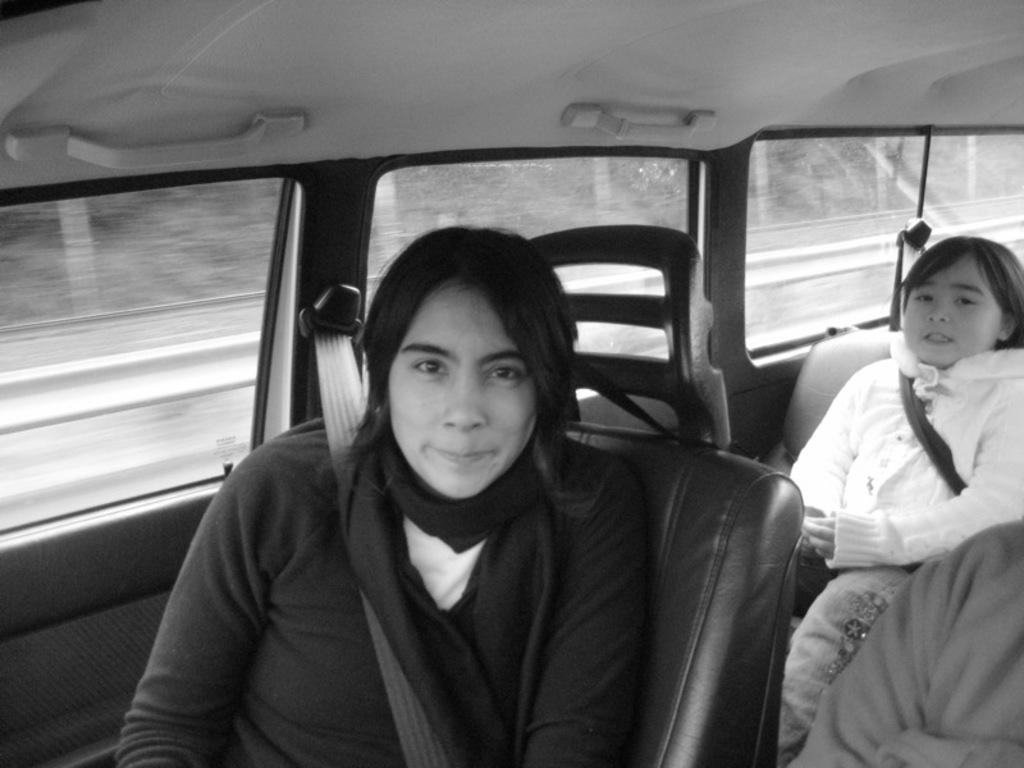How would you summarize this image in a sentence or two? In this picture we can see woman sitting on seat with seat belt and smiling and at back of her we can see a girl sitting on seat and they both are in some vehicle. 